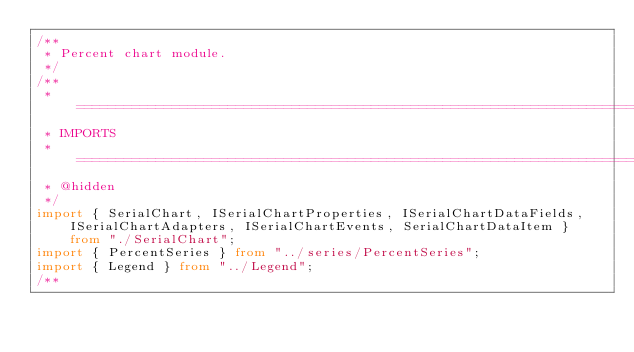<code> <loc_0><loc_0><loc_500><loc_500><_TypeScript_>/**
 * Percent chart module.
 */
/**
 * ============================================================================
 * IMPORTS
 * ============================================================================
 * @hidden
 */
import { SerialChart, ISerialChartProperties, ISerialChartDataFields, ISerialChartAdapters, ISerialChartEvents, SerialChartDataItem } from "./SerialChart";
import { PercentSeries } from "../series/PercentSeries";
import { Legend } from "../Legend";
/**</code> 